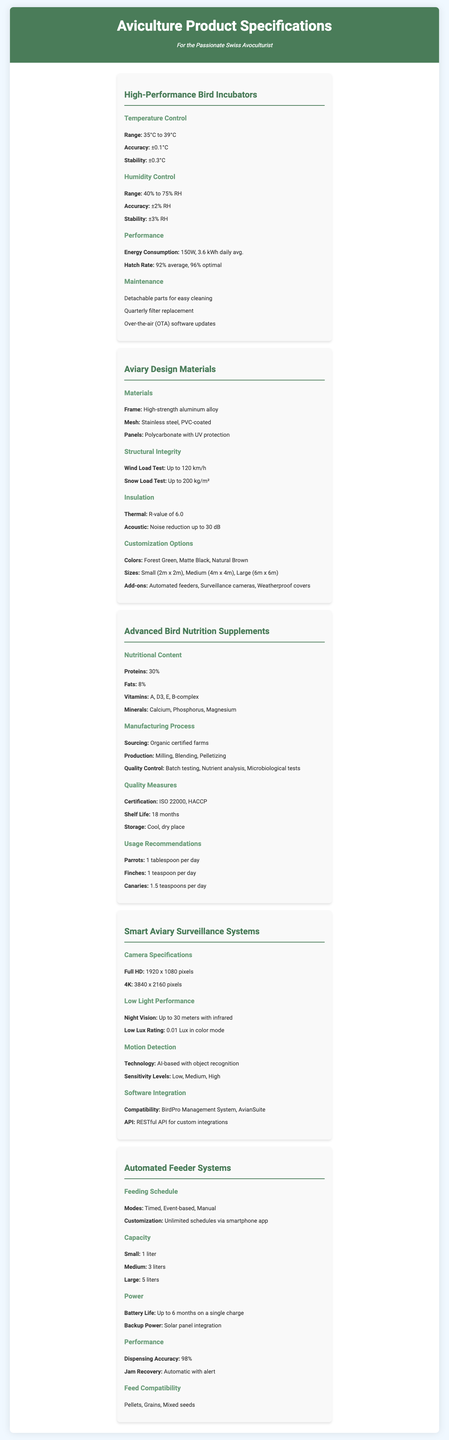What is the temperature control range for the incubators? The temperature control range is provided under the High-Performance Bird Incubators section.
Answer: 35°C to 39°C What is the average hatch rate for the incubators? The hatch rate statistics are mentioned in the Performance subsection of the High-Performance Bird Incubators.
Answer: 92% average What is the thermal insulation R-value of the aviary materials? The R-value for thermal insulation is stated under the Insulation section of Aviary Design Materials.
Answer: 6.0 What is the battery life for the automated feeder systems? The battery life is indicated in the power specifications for Automated Feeder Systems.
Answer: Up to 6 months What are the customization options available for aviary sizes? Customization options for sizes can be found in the Customization Options section of Aviary Design Materials.
Answer: Small (2m x 2m), Medium (4m x 4m), Large (6m x 6m) What is the dispensing accuracy of the automated feeder systems? The dispensing accuracy is mentioned in the Performance section of Automated Feeder Systems.
Answer: 98% What type of materials are used for the frame of the aviaries? The materials for the frame are specified under the Materials section in Aviary Design Materials.
Answer: High-strength aluminum alloy What is the low lux rating of the smart aviary surveillance systems in color mode? The low lux rating is detailed in the Low Light Performance subsection of Smart Aviary Surveillance Systems.
Answer: 0.01 Lux 